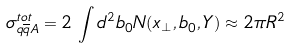<formula> <loc_0><loc_0><loc_500><loc_500>\sigma _ { q \overline { q } A } ^ { t o t } = 2 \, \int d ^ { 2 } b _ { 0 } N ( x _ { \perp } , b _ { 0 } , Y ) \approx 2 \pi R ^ { 2 }</formula> 